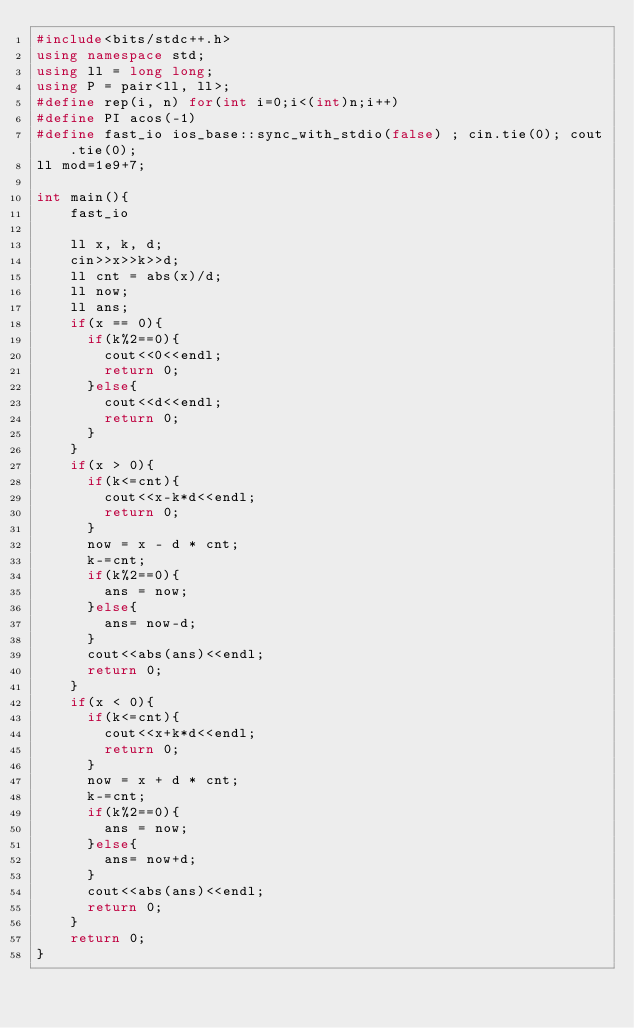<code> <loc_0><loc_0><loc_500><loc_500><_C++_>#include<bits/stdc++.h>
using namespace std;
using ll = long long;
using P = pair<ll, ll>;
#define rep(i, n) for(int i=0;i<(int)n;i++)
#define PI acos(-1)
#define fast_io ios_base::sync_with_stdio(false) ; cin.tie(0); cout.tie(0);
ll mod=1e9+7;

int main(){
    fast_io

    ll x, k, d;
    cin>>x>>k>>d;
    ll cnt = abs(x)/d;
    ll now;
    ll ans;
    if(x == 0){
      if(k%2==0){
        cout<<0<<endl;
        return 0;
      }else{
        cout<<d<<endl;
        return 0;
      }
    }
    if(x > 0){
      if(k<=cnt){
        cout<<x-k*d<<endl;
        return 0;
      }
      now = x - d * cnt;
      k-=cnt;
      if(k%2==0){
        ans = now;
      }else{
        ans= now-d;
      }
      cout<<abs(ans)<<endl;
      return 0;
    }
    if(x < 0){
      if(k<=cnt){
        cout<<x+k*d<<endl;
        return 0;
      }
      now = x + d * cnt;
      k-=cnt;
      if(k%2==0){
        ans = now;
      }else{
        ans= now+d;
      }
      cout<<abs(ans)<<endl;
      return 0;
    }
    return 0;
}
</code> 